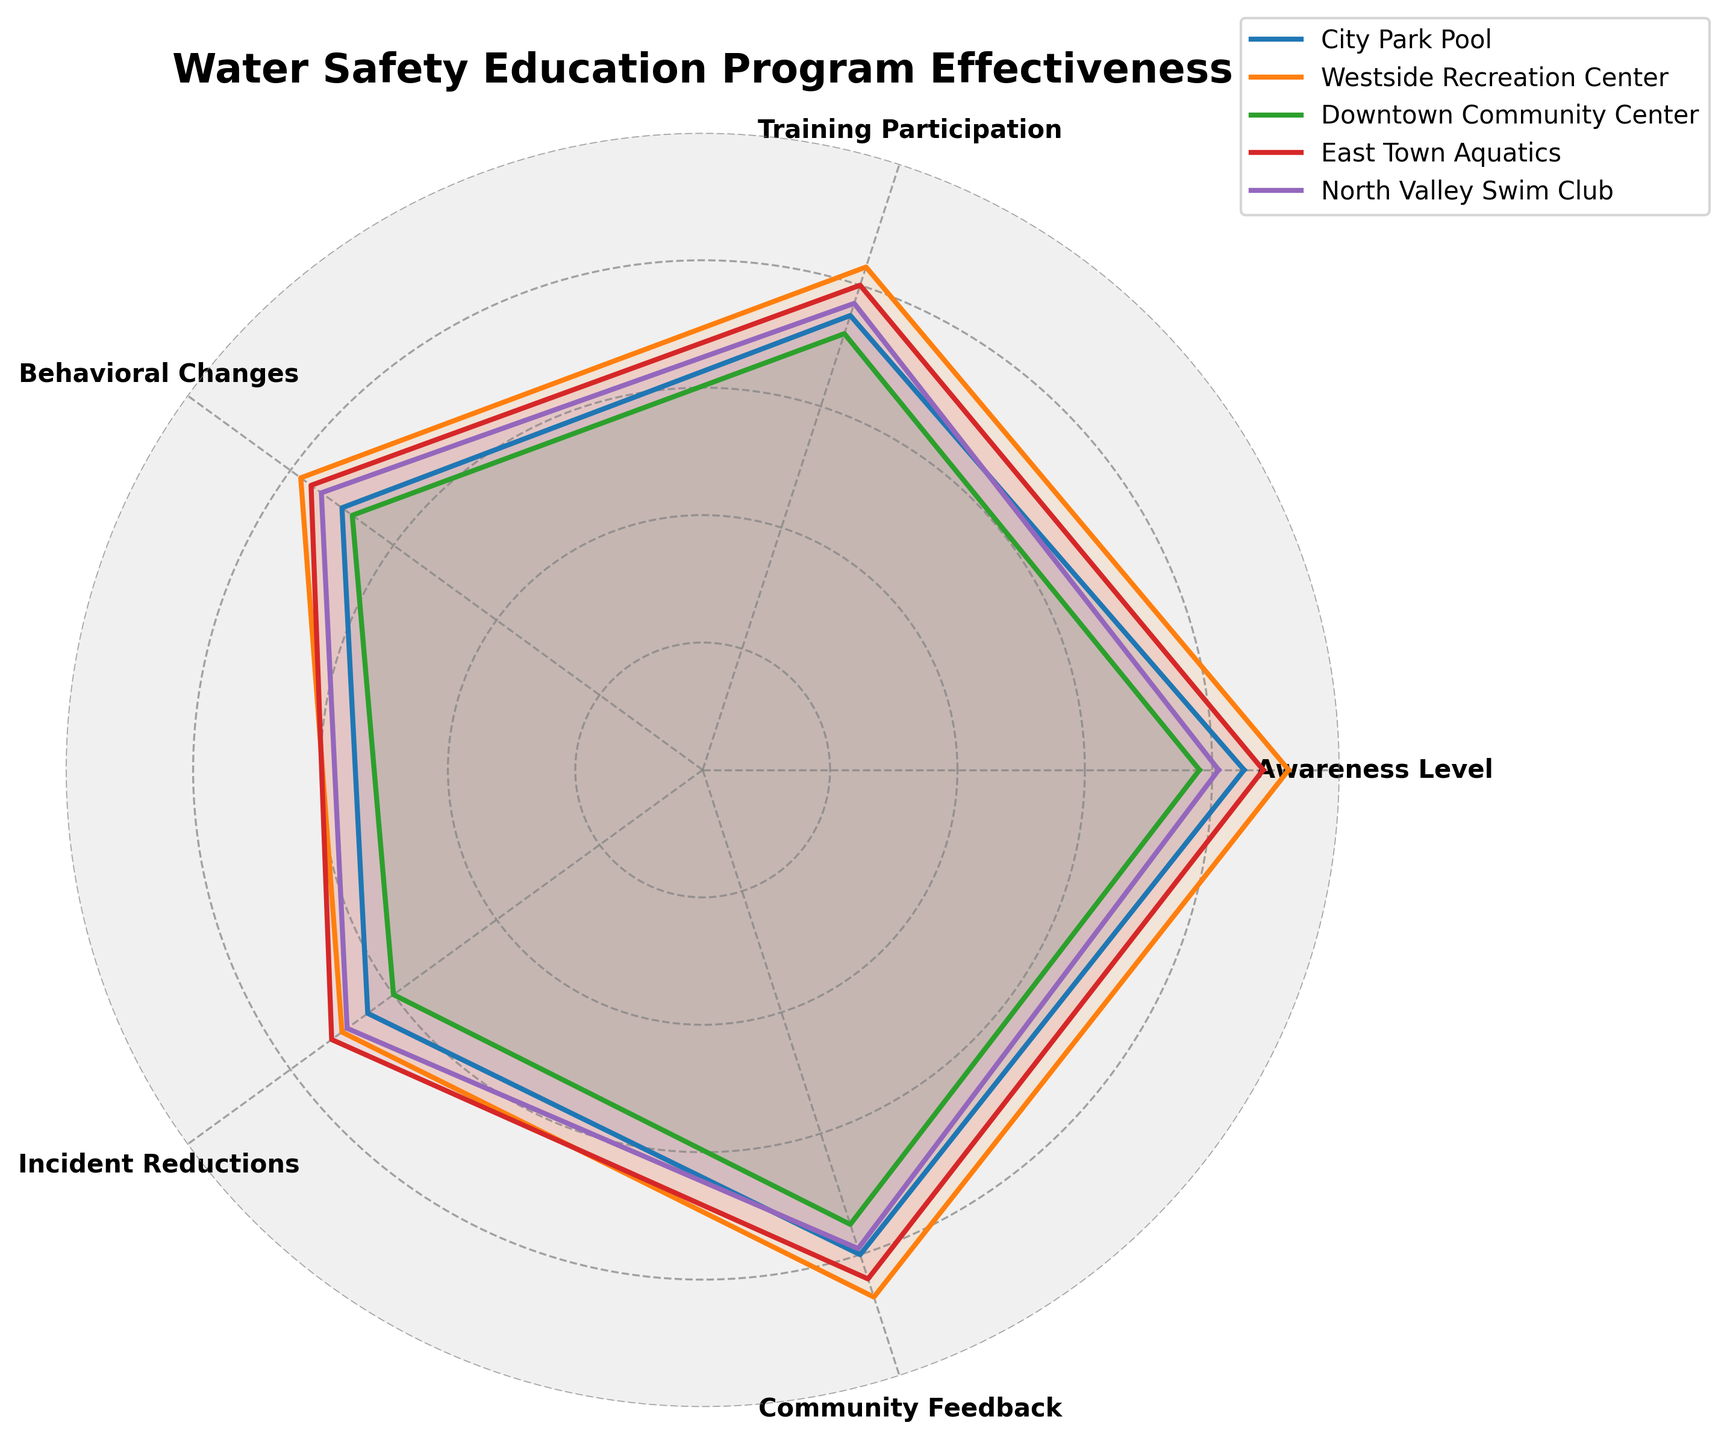What's the title of the radar chart? Look at the top part of the figure; the title is usually clearly marked there.
Answer: "Water Safety Education Program Effectiveness" How many community centers are compared in the radar chart? Count the distinct labels in the legend section of the chart. There are five community centers.
Answer: 5 Which community center has the highest Awareness Level? Awareness Level is one of the attributes around the radar chart. Identify the line that extends the furthest from the center at the "Awareness Level" point.
Answer: Westside Recreation Center What's the average value of Behavioral Changes across all centers? Sum the values for Behavioral Changes for all centers and then divide by the total number of centers: (70 + 78 + 68 + 76 + 74) / 5.
Answer: 73.2 Which attribute shows the most significant variation between the centers? Look for the attribute where the lines are most spread out (i.e., biggest visual difference between highest and lowest values).
Answer: Incident Reductions Between City Park Pool and East Town Aquatics, which center shows higher Training Participation? Locate the Training Participation attribute and compare the lengths of the respective lines for City Park Pool and East Town Aquatics.
Answer: East Town Aquatics Which center has the lowest value for Incident Reductions? Check the Incident Reduction attribute and identify which line is closest to the center point.
Answer: Downtown Community Center How does the Community Feedback at Downtown Community Center compare to that at North Valley Swim Club? Locate the Community Feedback attribute and compare the lengths of the lines for these two community centers.
Answer: Downtown Community Center is higher What's the total sum of Training Participation values across all centers? Add up the Training Participation values for all centers: 75 + 83 + 72 + 80 + 77.
Answer: 387 Which center has the best overall performance considering all attributes? Identify the center whose line is the most extended (indicating higher values) for most of the attributes. Assess the average performance visually.
Answer: Westside Recreation Center 